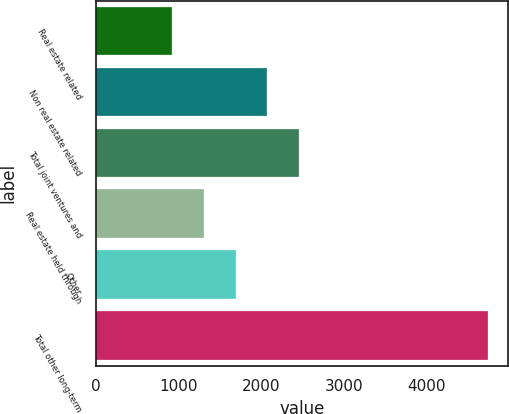Convert chart. <chart><loc_0><loc_0><loc_500><loc_500><bar_chart><fcel>Real estate related<fcel>Non real estate related<fcel>Total joint ventures and<fcel>Real estate held through<fcel>Other<fcel>Total other long-term<nl><fcel>923<fcel>2069.6<fcel>2451.8<fcel>1305.2<fcel>1687.4<fcel>4745<nl></chart> 